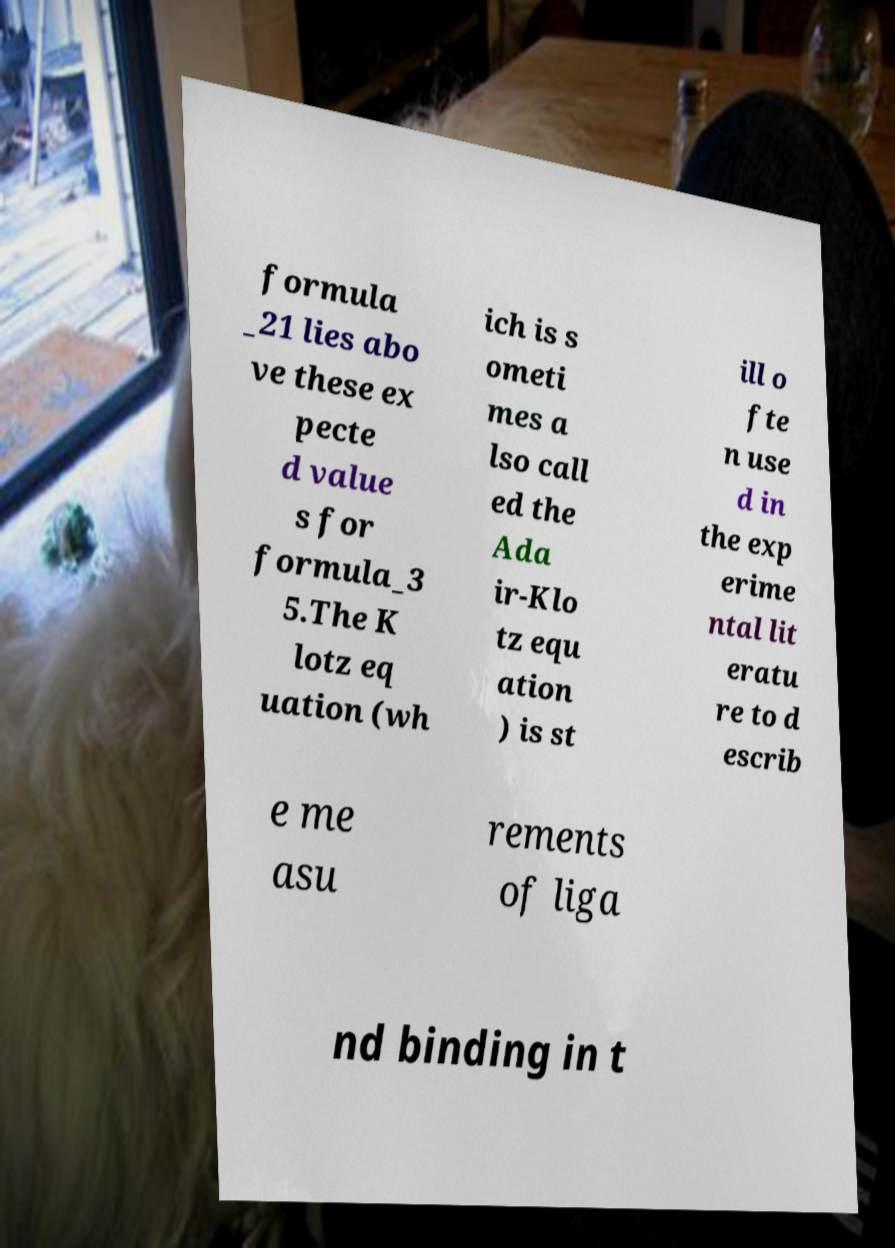I need the written content from this picture converted into text. Can you do that? formula _21 lies abo ve these ex pecte d value s for formula_3 5.The K lotz eq uation (wh ich is s ometi mes a lso call ed the Ada ir-Klo tz equ ation ) is st ill o fte n use d in the exp erime ntal lit eratu re to d escrib e me asu rements of liga nd binding in t 